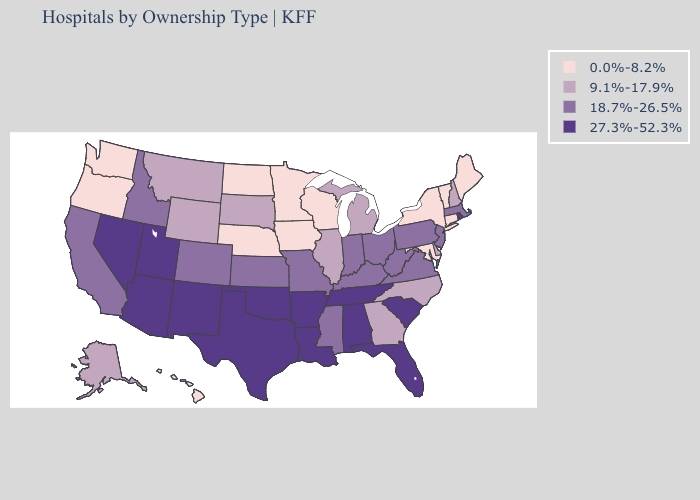What is the highest value in the South ?
Give a very brief answer. 27.3%-52.3%. Name the states that have a value in the range 27.3%-52.3%?
Keep it brief. Alabama, Arizona, Arkansas, Florida, Louisiana, Nevada, New Mexico, Oklahoma, Rhode Island, South Carolina, Tennessee, Texas, Utah. Does the map have missing data?
Give a very brief answer. No. Among the states that border Nevada , which have the lowest value?
Be succinct. Oregon. How many symbols are there in the legend?
Keep it brief. 4. Does the map have missing data?
Keep it brief. No. Which states have the lowest value in the West?
Short answer required. Hawaii, Oregon, Washington. What is the lowest value in states that border Kentucky?
Keep it brief. 9.1%-17.9%. Does Oklahoma have the highest value in the USA?
Short answer required. Yes. What is the highest value in states that border Texas?
Give a very brief answer. 27.3%-52.3%. Among the states that border Montana , does Wyoming have the lowest value?
Be succinct. No. Name the states that have a value in the range 18.7%-26.5%?
Quick response, please. California, Colorado, Idaho, Indiana, Kansas, Kentucky, Massachusetts, Mississippi, Missouri, New Jersey, Ohio, Pennsylvania, Virginia, West Virginia. What is the value of Washington?
Concise answer only. 0.0%-8.2%. Name the states that have a value in the range 9.1%-17.9%?
Give a very brief answer. Alaska, Delaware, Georgia, Illinois, Michigan, Montana, New Hampshire, North Carolina, South Dakota, Wyoming. Does Maine have the lowest value in the USA?
Quick response, please. Yes. 